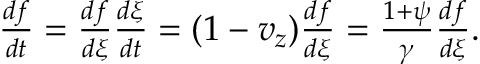Convert formula to latex. <formula><loc_0><loc_0><loc_500><loc_500>\begin{array} { r } { \frac { d f } { d t } = \frac { d f } { d \xi } \frac { d \xi } { d t } = ( 1 - v _ { z } ) \frac { d f } { d \xi } = \frac { 1 + \psi } { \gamma } \frac { d f } { d \xi } . } \end{array}</formula> 